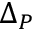<formula> <loc_0><loc_0><loc_500><loc_500>\Delta _ { P }</formula> 